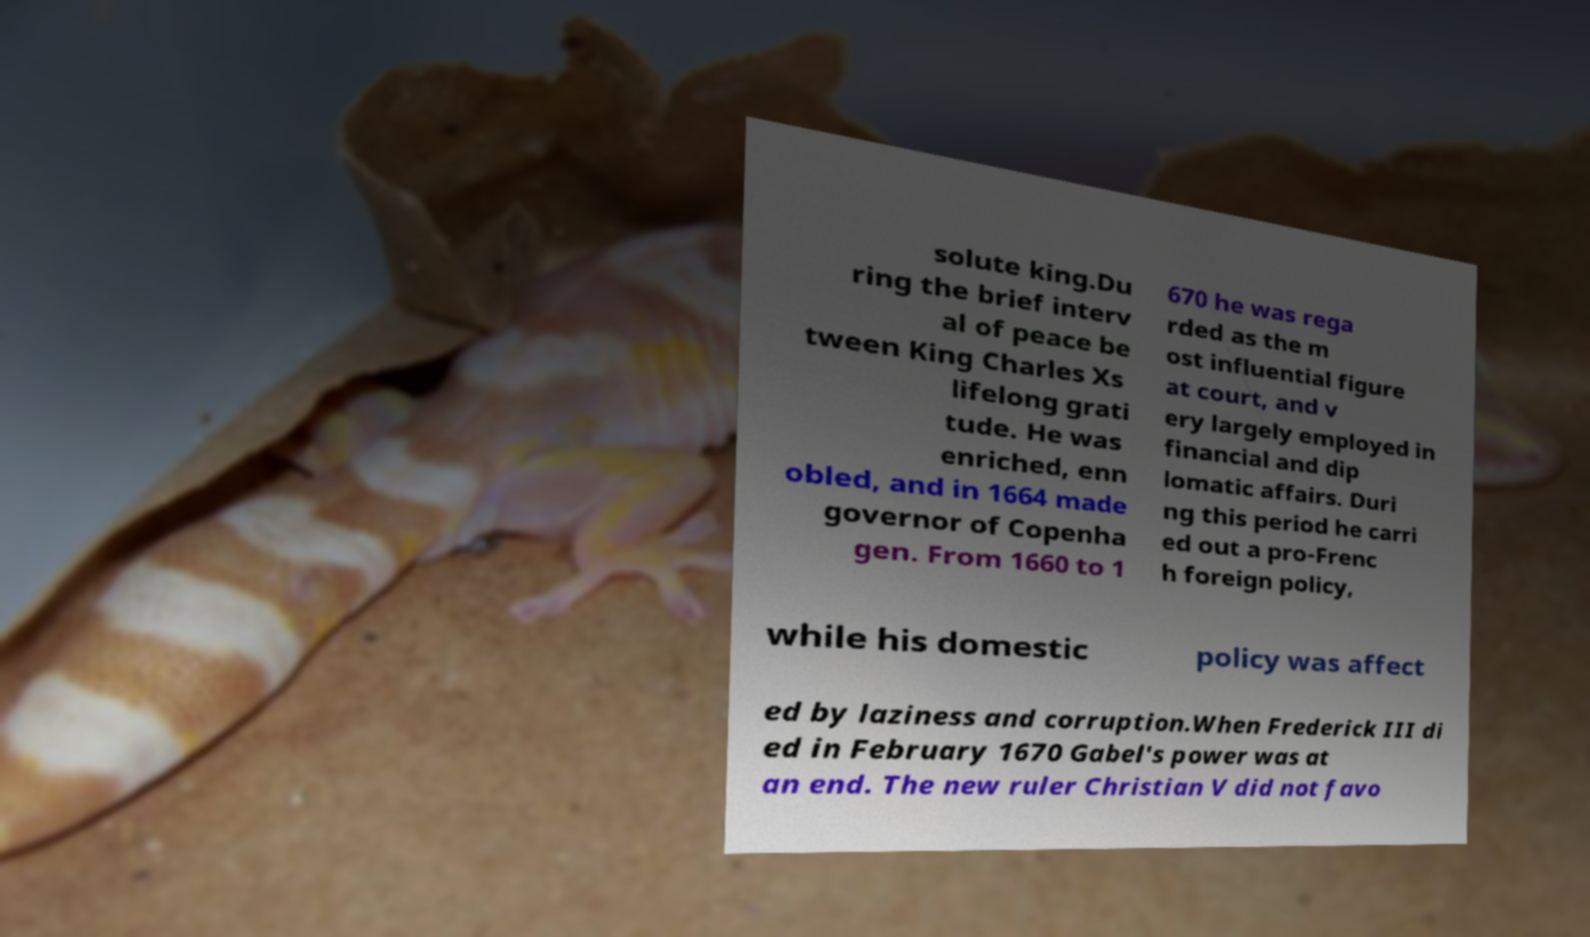I need the written content from this picture converted into text. Can you do that? solute king.Du ring the brief interv al of peace be tween King Charles Xs lifelong grati tude. He was enriched, enn obled, and in 1664 made governor of Copenha gen. From 1660 to 1 670 he was rega rded as the m ost influential figure at court, and v ery largely employed in financial and dip lomatic affairs. Duri ng this period he carri ed out a pro-Frenc h foreign policy, while his domestic policy was affect ed by laziness and corruption.When Frederick III di ed in February 1670 Gabel's power was at an end. The new ruler Christian V did not favo 